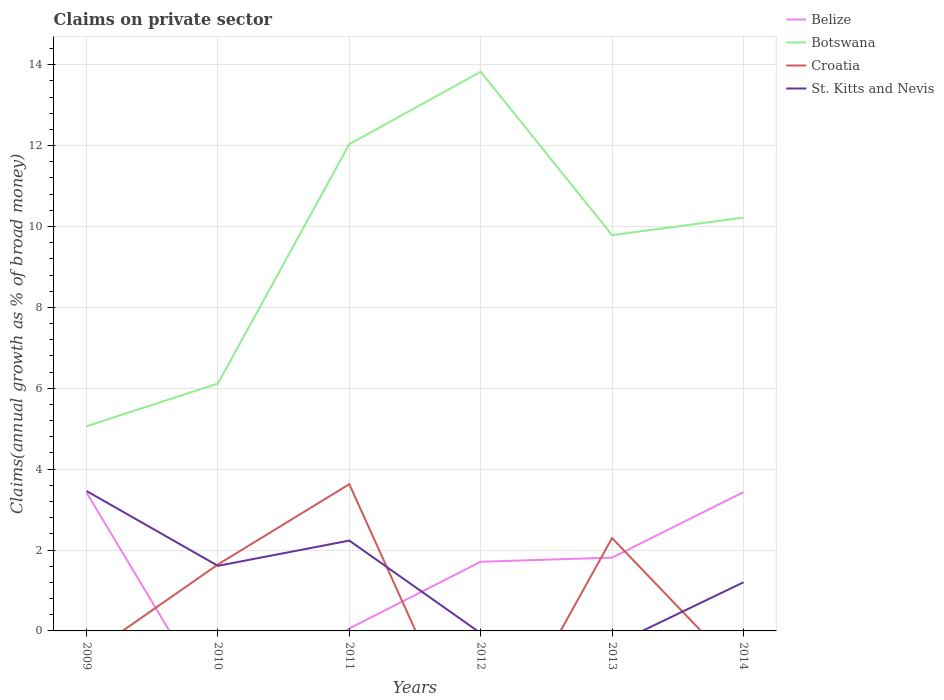How many different coloured lines are there?
Ensure brevity in your answer.  4. Does the line corresponding to Botswana intersect with the line corresponding to St. Kitts and Nevis?
Make the answer very short. No. Is the number of lines equal to the number of legend labels?
Give a very brief answer. No. What is the total percentage of broad money claimed on private sector in Croatia in the graph?
Your answer should be very brief. -1.99. What is the difference between the highest and the second highest percentage of broad money claimed on private sector in Botswana?
Offer a terse response. 8.77. Is the percentage of broad money claimed on private sector in Botswana strictly greater than the percentage of broad money claimed on private sector in Belize over the years?
Provide a short and direct response. No. Are the values on the major ticks of Y-axis written in scientific E-notation?
Your response must be concise. No. Where does the legend appear in the graph?
Your response must be concise. Top right. What is the title of the graph?
Keep it short and to the point. Claims on private sector. Does "Tuvalu" appear as one of the legend labels in the graph?
Make the answer very short. No. What is the label or title of the X-axis?
Provide a succinct answer. Years. What is the label or title of the Y-axis?
Provide a short and direct response. Claims(annual growth as % of broad money). What is the Claims(annual growth as % of broad money) in Belize in 2009?
Keep it short and to the point. 3.42. What is the Claims(annual growth as % of broad money) in Botswana in 2009?
Provide a short and direct response. 5.06. What is the Claims(annual growth as % of broad money) of St. Kitts and Nevis in 2009?
Provide a short and direct response. 3.46. What is the Claims(annual growth as % of broad money) in Botswana in 2010?
Make the answer very short. 6.12. What is the Claims(annual growth as % of broad money) in Croatia in 2010?
Keep it short and to the point. 1.64. What is the Claims(annual growth as % of broad money) in St. Kitts and Nevis in 2010?
Give a very brief answer. 1.61. What is the Claims(annual growth as % of broad money) in Belize in 2011?
Provide a succinct answer. 0.06. What is the Claims(annual growth as % of broad money) in Botswana in 2011?
Keep it short and to the point. 12.04. What is the Claims(annual growth as % of broad money) of Croatia in 2011?
Provide a succinct answer. 3.63. What is the Claims(annual growth as % of broad money) of St. Kitts and Nevis in 2011?
Offer a very short reply. 2.23. What is the Claims(annual growth as % of broad money) in Belize in 2012?
Give a very brief answer. 1.71. What is the Claims(annual growth as % of broad money) of Botswana in 2012?
Ensure brevity in your answer.  13.83. What is the Claims(annual growth as % of broad money) of St. Kitts and Nevis in 2012?
Your response must be concise. 0. What is the Claims(annual growth as % of broad money) in Belize in 2013?
Your answer should be compact. 1.81. What is the Claims(annual growth as % of broad money) in Botswana in 2013?
Your response must be concise. 9.79. What is the Claims(annual growth as % of broad money) in Croatia in 2013?
Your answer should be very brief. 2.3. What is the Claims(annual growth as % of broad money) of Belize in 2014?
Your answer should be very brief. 3.43. What is the Claims(annual growth as % of broad money) in Botswana in 2014?
Keep it short and to the point. 10.22. What is the Claims(annual growth as % of broad money) in Croatia in 2014?
Your answer should be very brief. 0. What is the Claims(annual growth as % of broad money) in St. Kitts and Nevis in 2014?
Your answer should be compact. 1.2. Across all years, what is the maximum Claims(annual growth as % of broad money) in Belize?
Ensure brevity in your answer.  3.43. Across all years, what is the maximum Claims(annual growth as % of broad money) of Botswana?
Provide a short and direct response. 13.83. Across all years, what is the maximum Claims(annual growth as % of broad money) of Croatia?
Your answer should be very brief. 3.63. Across all years, what is the maximum Claims(annual growth as % of broad money) of St. Kitts and Nevis?
Provide a succinct answer. 3.46. Across all years, what is the minimum Claims(annual growth as % of broad money) in Belize?
Your answer should be very brief. 0. Across all years, what is the minimum Claims(annual growth as % of broad money) of Botswana?
Make the answer very short. 5.06. What is the total Claims(annual growth as % of broad money) of Belize in the graph?
Provide a short and direct response. 10.43. What is the total Claims(annual growth as % of broad money) in Botswana in the graph?
Your response must be concise. 57.05. What is the total Claims(annual growth as % of broad money) in Croatia in the graph?
Keep it short and to the point. 7.57. What is the total Claims(annual growth as % of broad money) in St. Kitts and Nevis in the graph?
Offer a very short reply. 8.5. What is the difference between the Claims(annual growth as % of broad money) in Botswana in 2009 and that in 2010?
Provide a short and direct response. -1.06. What is the difference between the Claims(annual growth as % of broad money) of St. Kitts and Nevis in 2009 and that in 2010?
Your response must be concise. 1.85. What is the difference between the Claims(annual growth as % of broad money) in Belize in 2009 and that in 2011?
Ensure brevity in your answer.  3.36. What is the difference between the Claims(annual growth as % of broad money) in Botswana in 2009 and that in 2011?
Keep it short and to the point. -6.97. What is the difference between the Claims(annual growth as % of broad money) in St. Kitts and Nevis in 2009 and that in 2011?
Provide a short and direct response. 1.23. What is the difference between the Claims(annual growth as % of broad money) of Belize in 2009 and that in 2012?
Provide a succinct answer. 1.71. What is the difference between the Claims(annual growth as % of broad money) of Botswana in 2009 and that in 2012?
Ensure brevity in your answer.  -8.77. What is the difference between the Claims(annual growth as % of broad money) in Belize in 2009 and that in 2013?
Provide a short and direct response. 1.61. What is the difference between the Claims(annual growth as % of broad money) in Botswana in 2009 and that in 2013?
Your answer should be very brief. -4.73. What is the difference between the Claims(annual growth as % of broad money) of Belize in 2009 and that in 2014?
Ensure brevity in your answer.  -0.01. What is the difference between the Claims(annual growth as % of broad money) of Botswana in 2009 and that in 2014?
Provide a succinct answer. -5.16. What is the difference between the Claims(annual growth as % of broad money) in St. Kitts and Nevis in 2009 and that in 2014?
Give a very brief answer. 2.26. What is the difference between the Claims(annual growth as % of broad money) of Botswana in 2010 and that in 2011?
Your answer should be compact. -5.92. What is the difference between the Claims(annual growth as % of broad money) in Croatia in 2010 and that in 2011?
Give a very brief answer. -1.99. What is the difference between the Claims(annual growth as % of broad money) in St. Kitts and Nevis in 2010 and that in 2011?
Your answer should be compact. -0.62. What is the difference between the Claims(annual growth as % of broad money) in Botswana in 2010 and that in 2012?
Your answer should be very brief. -7.71. What is the difference between the Claims(annual growth as % of broad money) of Botswana in 2010 and that in 2013?
Offer a very short reply. -3.67. What is the difference between the Claims(annual growth as % of broad money) in Croatia in 2010 and that in 2013?
Provide a short and direct response. -0.65. What is the difference between the Claims(annual growth as % of broad money) of Botswana in 2010 and that in 2014?
Offer a very short reply. -4.1. What is the difference between the Claims(annual growth as % of broad money) in St. Kitts and Nevis in 2010 and that in 2014?
Offer a terse response. 0.41. What is the difference between the Claims(annual growth as % of broad money) in Belize in 2011 and that in 2012?
Offer a very short reply. -1.65. What is the difference between the Claims(annual growth as % of broad money) in Botswana in 2011 and that in 2012?
Give a very brief answer. -1.79. What is the difference between the Claims(annual growth as % of broad money) of Belize in 2011 and that in 2013?
Offer a terse response. -1.75. What is the difference between the Claims(annual growth as % of broad money) of Botswana in 2011 and that in 2013?
Your answer should be compact. 2.25. What is the difference between the Claims(annual growth as % of broad money) of Croatia in 2011 and that in 2013?
Provide a succinct answer. 1.33. What is the difference between the Claims(annual growth as % of broad money) in Belize in 2011 and that in 2014?
Give a very brief answer. -3.37. What is the difference between the Claims(annual growth as % of broad money) in Botswana in 2011 and that in 2014?
Your answer should be compact. 1.82. What is the difference between the Claims(annual growth as % of broad money) in St. Kitts and Nevis in 2011 and that in 2014?
Keep it short and to the point. 1.03. What is the difference between the Claims(annual growth as % of broad money) of Belize in 2012 and that in 2013?
Offer a terse response. -0.1. What is the difference between the Claims(annual growth as % of broad money) in Botswana in 2012 and that in 2013?
Keep it short and to the point. 4.04. What is the difference between the Claims(annual growth as % of broad money) in Belize in 2012 and that in 2014?
Offer a terse response. -1.72. What is the difference between the Claims(annual growth as % of broad money) in Botswana in 2012 and that in 2014?
Provide a short and direct response. 3.61. What is the difference between the Claims(annual growth as % of broad money) in Belize in 2013 and that in 2014?
Offer a terse response. -1.62. What is the difference between the Claims(annual growth as % of broad money) of Botswana in 2013 and that in 2014?
Your answer should be compact. -0.43. What is the difference between the Claims(annual growth as % of broad money) of Belize in 2009 and the Claims(annual growth as % of broad money) of Botswana in 2010?
Your response must be concise. -2.7. What is the difference between the Claims(annual growth as % of broad money) in Belize in 2009 and the Claims(annual growth as % of broad money) in Croatia in 2010?
Your response must be concise. 1.78. What is the difference between the Claims(annual growth as % of broad money) of Belize in 2009 and the Claims(annual growth as % of broad money) of St. Kitts and Nevis in 2010?
Make the answer very short. 1.81. What is the difference between the Claims(annual growth as % of broad money) in Botswana in 2009 and the Claims(annual growth as % of broad money) in Croatia in 2010?
Make the answer very short. 3.42. What is the difference between the Claims(annual growth as % of broad money) of Botswana in 2009 and the Claims(annual growth as % of broad money) of St. Kitts and Nevis in 2010?
Keep it short and to the point. 3.45. What is the difference between the Claims(annual growth as % of broad money) in Belize in 2009 and the Claims(annual growth as % of broad money) in Botswana in 2011?
Give a very brief answer. -8.62. What is the difference between the Claims(annual growth as % of broad money) in Belize in 2009 and the Claims(annual growth as % of broad money) in Croatia in 2011?
Ensure brevity in your answer.  -0.21. What is the difference between the Claims(annual growth as % of broad money) in Belize in 2009 and the Claims(annual growth as % of broad money) in St. Kitts and Nevis in 2011?
Keep it short and to the point. 1.19. What is the difference between the Claims(annual growth as % of broad money) of Botswana in 2009 and the Claims(annual growth as % of broad money) of Croatia in 2011?
Your response must be concise. 1.43. What is the difference between the Claims(annual growth as % of broad money) of Botswana in 2009 and the Claims(annual growth as % of broad money) of St. Kitts and Nevis in 2011?
Offer a very short reply. 2.83. What is the difference between the Claims(annual growth as % of broad money) in Belize in 2009 and the Claims(annual growth as % of broad money) in Botswana in 2012?
Give a very brief answer. -10.41. What is the difference between the Claims(annual growth as % of broad money) in Belize in 2009 and the Claims(annual growth as % of broad money) in Botswana in 2013?
Your response must be concise. -6.37. What is the difference between the Claims(annual growth as % of broad money) in Belize in 2009 and the Claims(annual growth as % of broad money) in Croatia in 2013?
Make the answer very short. 1.12. What is the difference between the Claims(annual growth as % of broad money) in Botswana in 2009 and the Claims(annual growth as % of broad money) in Croatia in 2013?
Make the answer very short. 2.76. What is the difference between the Claims(annual growth as % of broad money) of Belize in 2009 and the Claims(annual growth as % of broad money) of Botswana in 2014?
Your answer should be very brief. -6.8. What is the difference between the Claims(annual growth as % of broad money) of Belize in 2009 and the Claims(annual growth as % of broad money) of St. Kitts and Nevis in 2014?
Your answer should be compact. 2.22. What is the difference between the Claims(annual growth as % of broad money) of Botswana in 2009 and the Claims(annual growth as % of broad money) of St. Kitts and Nevis in 2014?
Keep it short and to the point. 3.86. What is the difference between the Claims(annual growth as % of broad money) in Botswana in 2010 and the Claims(annual growth as % of broad money) in Croatia in 2011?
Offer a terse response. 2.49. What is the difference between the Claims(annual growth as % of broad money) of Botswana in 2010 and the Claims(annual growth as % of broad money) of St. Kitts and Nevis in 2011?
Offer a terse response. 3.88. What is the difference between the Claims(annual growth as % of broad money) in Croatia in 2010 and the Claims(annual growth as % of broad money) in St. Kitts and Nevis in 2011?
Your response must be concise. -0.59. What is the difference between the Claims(annual growth as % of broad money) of Botswana in 2010 and the Claims(annual growth as % of broad money) of Croatia in 2013?
Offer a terse response. 3.82. What is the difference between the Claims(annual growth as % of broad money) in Botswana in 2010 and the Claims(annual growth as % of broad money) in St. Kitts and Nevis in 2014?
Give a very brief answer. 4.92. What is the difference between the Claims(annual growth as % of broad money) in Croatia in 2010 and the Claims(annual growth as % of broad money) in St. Kitts and Nevis in 2014?
Provide a short and direct response. 0.44. What is the difference between the Claims(annual growth as % of broad money) of Belize in 2011 and the Claims(annual growth as % of broad money) of Botswana in 2012?
Provide a succinct answer. -13.77. What is the difference between the Claims(annual growth as % of broad money) in Belize in 2011 and the Claims(annual growth as % of broad money) in Botswana in 2013?
Your answer should be very brief. -9.73. What is the difference between the Claims(annual growth as % of broad money) of Belize in 2011 and the Claims(annual growth as % of broad money) of Croatia in 2013?
Keep it short and to the point. -2.24. What is the difference between the Claims(annual growth as % of broad money) in Botswana in 2011 and the Claims(annual growth as % of broad money) in Croatia in 2013?
Give a very brief answer. 9.74. What is the difference between the Claims(annual growth as % of broad money) of Belize in 2011 and the Claims(annual growth as % of broad money) of Botswana in 2014?
Offer a terse response. -10.16. What is the difference between the Claims(annual growth as % of broad money) of Belize in 2011 and the Claims(annual growth as % of broad money) of St. Kitts and Nevis in 2014?
Your response must be concise. -1.14. What is the difference between the Claims(annual growth as % of broad money) of Botswana in 2011 and the Claims(annual growth as % of broad money) of St. Kitts and Nevis in 2014?
Provide a short and direct response. 10.83. What is the difference between the Claims(annual growth as % of broad money) in Croatia in 2011 and the Claims(annual growth as % of broad money) in St. Kitts and Nevis in 2014?
Provide a succinct answer. 2.43. What is the difference between the Claims(annual growth as % of broad money) in Belize in 2012 and the Claims(annual growth as % of broad money) in Botswana in 2013?
Your response must be concise. -8.08. What is the difference between the Claims(annual growth as % of broad money) in Belize in 2012 and the Claims(annual growth as % of broad money) in Croatia in 2013?
Offer a terse response. -0.59. What is the difference between the Claims(annual growth as % of broad money) of Botswana in 2012 and the Claims(annual growth as % of broad money) of Croatia in 2013?
Offer a terse response. 11.53. What is the difference between the Claims(annual growth as % of broad money) in Belize in 2012 and the Claims(annual growth as % of broad money) in Botswana in 2014?
Your response must be concise. -8.51. What is the difference between the Claims(annual growth as % of broad money) in Belize in 2012 and the Claims(annual growth as % of broad money) in St. Kitts and Nevis in 2014?
Provide a short and direct response. 0.51. What is the difference between the Claims(annual growth as % of broad money) in Botswana in 2012 and the Claims(annual growth as % of broad money) in St. Kitts and Nevis in 2014?
Your answer should be very brief. 12.63. What is the difference between the Claims(annual growth as % of broad money) in Belize in 2013 and the Claims(annual growth as % of broad money) in Botswana in 2014?
Provide a succinct answer. -8.41. What is the difference between the Claims(annual growth as % of broad money) of Belize in 2013 and the Claims(annual growth as % of broad money) of St. Kitts and Nevis in 2014?
Keep it short and to the point. 0.61. What is the difference between the Claims(annual growth as % of broad money) of Botswana in 2013 and the Claims(annual growth as % of broad money) of St. Kitts and Nevis in 2014?
Offer a terse response. 8.58. What is the difference between the Claims(annual growth as % of broad money) of Croatia in 2013 and the Claims(annual growth as % of broad money) of St. Kitts and Nevis in 2014?
Your answer should be very brief. 1.1. What is the average Claims(annual growth as % of broad money) in Belize per year?
Give a very brief answer. 1.74. What is the average Claims(annual growth as % of broad money) in Botswana per year?
Ensure brevity in your answer.  9.51. What is the average Claims(annual growth as % of broad money) of Croatia per year?
Ensure brevity in your answer.  1.26. What is the average Claims(annual growth as % of broad money) of St. Kitts and Nevis per year?
Keep it short and to the point. 1.42. In the year 2009, what is the difference between the Claims(annual growth as % of broad money) of Belize and Claims(annual growth as % of broad money) of Botswana?
Keep it short and to the point. -1.64. In the year 2009, what is the difference between the Claims(annual growth as % of broad money) in Belize and Claims(annual growth as % of broad money) in St. Kitts and Nevis?
Your response must be concise. -0.04. In the year 2009, what is the difference between the Claims(annual growth as % of broad money) of Botswana and Claims(annual growth as % of broad money) of St. Kitts and Nevis?
Your response must be concise. 1.6. In the year 2010, what is the difference between the Claims(annual growth as % of broad money) of Botswana and Claims(annual growth as % of broad money) of Croatia?
Your answer should be compact. 4.47. In the year 2010, what is the difference between the Claims(annual growth as % of broad money) of Botswana and Claims(annual growth as % of broad money) of St. Kitts and Nevis?
Your answer should be compact. 4.51. In the year 2010, what is the difference between the Claims(annual growth as % of broad money) in Croatia and Claims(annual growth as % of broad money) in St. Kitts and Nevis?
Provide a short and direct response. 0.03. In the year 2011, what is the difference between the Claims(annual growth as % of broad money) in Belize and Claims(annual growth as % of broad money) in Botswana?
Your answer should be very brief. -11.98. In the year 2011, what is the difference between the Claims(annual growth as % of broad money) in Belize and Claims(annual growth as % of broad money) in Croatia?
Offer a terse response. -3.57. In the year 2011, what is the difference between the Claims(annual growth as % of broad money) of Belize and Claims(annual growth as % of broad money) of St. Kitts and Nevis?
Provide a succinct answer. -2.17. In the year 2011, what is the difference between the Claims(annual growth as % of broad money) of Botswana and Claims(annual growth as % of broad money) of Croatia?
Offer a very short reply. 8.41. In the year 2011, what is the difference between the Claims(annual growth as % of broad money) in Botswana and Claims(annual growth as % of broad money) in St. Kitts and Nevis?
Ensure brevity in your answer.  9.8. In the year 2011, what is the difference between the Claims(annual growth as % of broad money) of Croatia and Claims(annual growth as % of broad money) of St. Kitts and Nevis?
Offer a terse response. 1.4. In the year 2012, what is the difference between the Claims(annual growth as % of broad money) of Belize and Claims(annual growth as % of broad money) of Botswana?
Make the answer very short. -12.12. In the year 2013, what is the difference between the Claims(annual growth as % of broad money) of Belize and Claims(annual growth as % of broad money) of Botswana?
Keep it short and to the point. -7.97. In the year 2013, what is the difference between the Claims(annual growth as % of broad money) in Belize and Claims(annual growth as % of broad money) in Croatia?
Provide a short and direct response. -0.48. In the year 2013, what is the difference between the Claims(annual growth as % of broad money) of Botswana and Claims(annual growth as % of broad money) of Croatia?
Provide a short and direct response. 7.49. In the year 2014, what is the difference between the Claims(annual growth as % of broad money) of Belize and Claims(annual growth as % of broad money) of Botswana?
Make the answer very short. -6.79. In the year 2014, what is the difference between the Claims(annual growth as % of broad money) in Belize and Claims(annual growth as % of broad money) in St. Kitts and Nevis?
Provide a short and direct response. 2.23. In the year 2014, what is the difference between the Claims(annual growth as % of broad money) in Botswana and Claims(annual growth as % of broad money) in St. Kitts and Nevis?
Offer a terse response. 9.02. What is the ratio of the Claims(annual growth as % of broad money) of Botswana in 2009 to that in 2010?
Your answer should be very brief. 0.83. What is the ratio of the Claims(annual growth as % of broad money) of St. Kitts and Nevis in 2009 to that in 2010?
Ensure brevity in your answer.  2.15. What is the ratio of the Claims(annual growth as % of broad money) in Belize in 2009 to that in 2011?
Make the answer very short. 56.88. What is the ratio of the Claims(annual growth as % of broad money) of Botswana in 2009 to that in 2011?
Your answer should be compact. 0.42. What is the ratio of the Claims(annual growth as % of broad money) in St. Kitts and Nevis in 2009 to that in 2011?
Provide a short and direct response. 1.55. What is the ratio of the Claims(annual growth as % of broad money) in Belize in 2009 to that in 2012?
Provide a short and direct response. 2. What is the ratio of the Claims(annual growth as % of broad money) in Botswana in 2009 to that in 2012?
Your response must be concise. 0.37. What is the ratio of the Claims(annual growth as % of broad money) in Belize in 2009 to that in 2013?
Provide a short and direct response. 1.89. What is the ratio of the Claims(annual growth as % of broad money) in Botswana in 2009 to that in 2013?
Your answer should be compact. 0.52. What is the ratio of the Claims(annual growth as % of broad money) of Botswana in 2009 to that in 2014?
Your answer should be compact. 0.5. What is the ratio of the Claims(annual growth as % of broad money) of St. Kitts and Nevis in 2009 to that in 2014?
Your answer should be very brief. 2.88. What is the ratio of the Claims(annual growth as % of broad money) of Botswana in 2010 to that in 2011?
Offer a terse response. 0.51. What is the ratio of the Claims(annual growth as % of broad money) in Croatia in 2010 to that in 2011?
Keep it short and to the point. 0.45. What is the ratio of the Claims(annual growth as % of broad money) in St. Kitts and Nevis in 2010 to that in 2011?
Provide a short and direct response. 0.72. What is the ratio of the Claims(annual growth as % of broad money) in Botswana in 2010 to that in 2012?
Offer a terse response. 0.44. What is the ratio of the Claims(annual growth as % of broad money) in Botswana in 2010 to that in 2013?
Ensure brevity in your answer.  0.63. What is the ratio of the Claims(annual growth as % of broad money) of Croatia in 2010 to that in 2013?
Provide a succinct answer. 0.72. What is the ratio of the Claims(annual growth as % of broad money) in Botswana in 2010 to that in 2014?
Provide a short and direct response. 0.6. What is the ratio of the Claims(annual growth as % of broad money) of St. Kitts and Nevis in 2010 to that in 2014?
Your answer should be compact. 1.34. What is the ratio of the Claims(annual growth as % of broad money) in Belize in 2011 to that in 2012?
Give a very brief answer. 0.04. What is the ratio of the Claims(annual growth as % of broad money) in Botswana in 2011 to that in 2012?
Provide a short and direct response. 0.87. What is the ratio of the Claims(annual growth as % of broad money) in Belize in 2011 to that in 2013?
Provide a short and direct response. 0.03. What is the ratio of the Claims(annual growth as % of broad money) in Botswana in 2011 to that in 2013?
Ensure brevity in your answer.  1.23. What is the ratio of the Claims(annual growth as % of broad money) of Croatia in 2011 to that in 2013?
Provide a succinct answer. 1.58. What is the ratio of the Claims(annual growth as % of broad money) in Belize in 2011 to that in 2014?
Make the answer very short. 0.02. What is the ratio of the Claims(annual growth as % of broad money) in Botswana in 2011 to that in 2014?
Offer a terse response. 1.18. What is the ratio of the Claims(annual growth as % of broad money) of St. Kitts and Nevis in 2011 to that in 2014?
Keep it short and to the point. 1.86. What is the ratio of the Claims(annual growth as % of broad money) in Belize in 2012 to that in 2013?
Offer a terse response. 0.94. What is the ratio of the Claims(annual growth as % of broad money) of Botswana in 2012 to that in 2013?
Make the answer very short. 1.41. What is the ratio of the Claims(annual growth as % of broad money) in Belize in 2012 to that in 2014?
Keep it short and to the point. 0.5. What is the ratio of the Claims(annual growth as % of broad money) in Botswana in 2012 to that in 2014?
Offer a very short reply. 1.35. What is the ratio of the Claims(annual growth as % of broad money) of Belize in 2013 to that in 2014?
Your answer should be very brief. 0.53. What is the ratio of the Claims(annual growth as % of broad money) of Botswana in 2013 to that in 2014?
Keep it short and to the point. 0.96. What is the difference between the highest and the second highest Claims(annual growth as % of broad money) of Belize?
Give a very brief answer. 0.01. What is the difference between the highest and the second highest Claims(annual growth as % of broad money) of Botswana?
Keep it short and to the point. 1.79. What is the difference between the highest and the second highest Claims(annual growth as % of broad money) in Croatia?
Make the answer very short. 1.33. What is the difference between the highest and the second highest Claims(annual growth as % of broad money) of St. Kitts and Nevis?
Provide a succinct answer. 1.23. What is the difference between the highest and the lowest Claims(annual growth as % of broad money) in Belize?
Your answer should be compact. 3.43. What is the difference between the highest and the lowest Claims(annual growth as % of broad money) in Botswana?
Your answer should be compact. 8.77. What is the difference between the highest and the lowest Claims(annual growth as % of broad money) of Croatia?
Give a very brief answer. 3.63. What is the difference between the highest and the lowest Claims(annual growth as % of broad money) of St. Kitts and Nevis?
Keep it short and to the point. 3.46. 